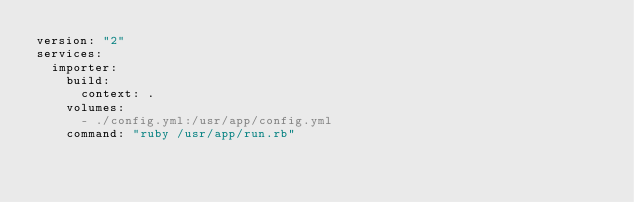<code> <loc_0><loc_0><loc_500><loc_500><_YAML_>version: "2"
services:
  importer:
    build:
      context: .
    volumes:
      - ./config.yml:/usr/app/config.yml
    command: "ruby /usr/app/run.rb"
</code> 